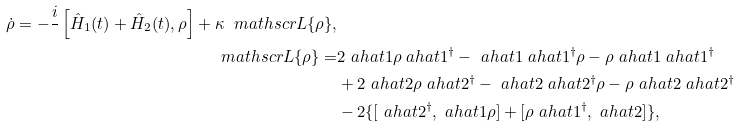<formula> <loc_0><loc_0><loc_500><loc_500>\dot { \rho } = - \frac { i } { } \left [ \hat { H } _ { 1 } ( t ) + \hat { H } _ { 2 } ( t ) , \rho \right ] + \kappa \ m a t h s c r { L } \{ \rho \} , \\ \ m a t h s c r { L } \{ \rho \} = & 2 \ a h a t { 1 } \rho \ a h a t { 1 } ^ { \dagger } - \ a h a t { 1 } \ a h a t { 1 } ^ { \dagger } \rho - \rho \ a h a t { 1 } \ a h a t { 1 } ^ { \dagger } \\ & + 2 \ a h a t { 2 } \rho \ a h a t { 2 } ^ { \dagger } - \ a h a t { 2 } \ a h a t { 2 } ^ { \dagger } \rho - \rho \ a h a t { 2 } \ a h a t { 2 } ^ { \dagger } \\ & - 2 \{ [ \ a h a t { 2 } ^ { \dagger } , \ a h a t { 1 } \rho ] + [ \rho \ a h a t { 1 } ^ { \dagger } , \ a h a t { 2 } ] \} ,</formula> 